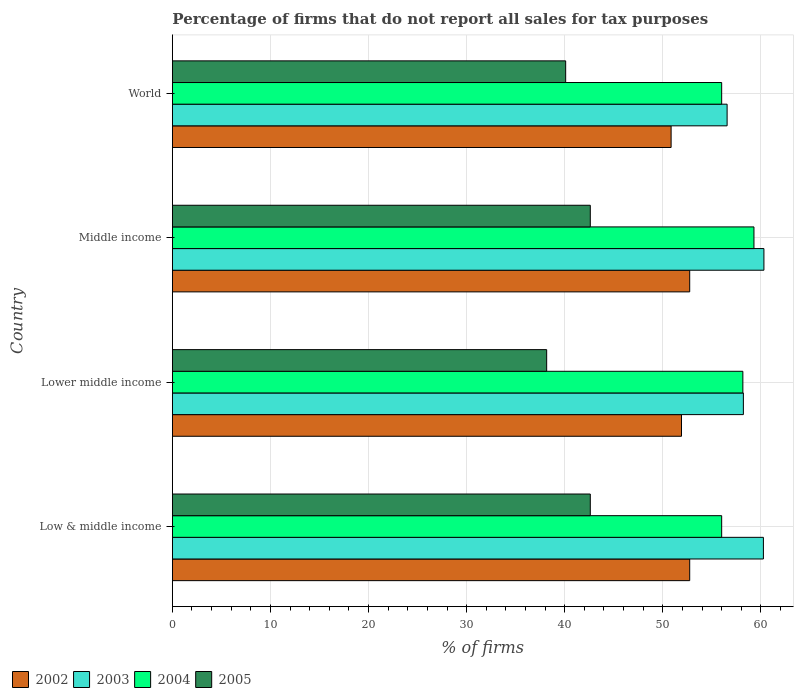How many different coloured bars are there?
Offer a terse response. 4. Are the number of bars on each tick of the Y-axis equal?
Your response must be concise. Yes. How many bars are there on the 1st tick from the top?
Your answer should be compact. 4. How many bars are there on the 2nd tick from the bottom?
Make the answer very short. 4. What is the label of the 3rd group of bars from the top?
Make the answer very short. Lower middle income. What is the percentage of firms that do not report all sales for tax purposes in 2004 in World?
Make the answer very short. 56.01. Across all countries, what is the maximum percentage of firms that do not report all sales for tax purposes in 2004?
Offer a very short reply. 59.3. Across all countries, what is the minimum percentage of firms that do not report all sales for tax purposes in 2005?
Keep it short and to the point. 38.16. In which country was the percentage of firms that do not report all sales for tax purposes in 2004 maximum?
Your response must be concise. Middle income. In which country was the percentage of firms that do not report all sales for tax purposes in 2004 minimum?
Give a very brief answer. Low & middle income. What is the total percentage of firms that do not report all sales for tax purposes in 2004 in the graph?
Provide a short and direct response. 229.47. What is the difference between the percentage of firms that do not report all sales for tax purposes in 2004 in Lower middle income and that in World?
Your answer should be compact. 2.16. What is the difference between the percentage of firms that do not report all sales for tax purposes in 2005 in Middle income and the percentage of firms that do not report all sales for tax purposes in 2004 in World?
Your response must be concise. -13.39. What is the average percentage of firms that do not report all sales for tax purposes in 2004 per country?
Keep it short and to the point. 57.37. What is the difference between the percentage of firms that do not report all sales for tax purposes in 2005 and percentage of firms that do not report all sales for tax purposes in 2004 in Middle income?
Give a very brief answer. -16.69. In how many countries, is the percentage of firms that do not report all sales for tax purposes in 2002 greater than 48 %?
Provide a short and direct response. 4. What is the ratio of the percentage of firms that do not report all sales for tax purposes in 2002 in Lower middle income to that in Middle income?
Give a very brief answer. 0.98. What is the difference between the highest and the second highest percentage of firms that do not report all sales for tax purposes in 2005?
Your answer should be compact. 0. What is the difference between the highest and the lowest percentage of firms that do not report all sales for tax purposes in 2003?
Give a very brief answer. 3.75. In how many countries, is the percentage of firms that do not report all sales for tax purposes in 2004 greater than the average percentage of firms that do not report all sales for tax purposes in 2004 taken over all countries?
Ensure brevity in your answer.  2. Is the sum of the percentage of firms that do not report all sales for tax purposes in 2004 in Low & middle income and World greater than the maximum percentage of firms that do not report all sales for tax purposes in 2003 across all countries?
Offer a terse response. Yes. Is it the case that in every country, the sum of the percentage of firms that do not report all sales for tax purposes in 2005 and percentage of firms that do not report all sales for tax purposes in 2002 is greater than the sum of percentage of firms that do not report all sales for tax purposes in 2004 and percentage of firms that do not report all sales for tax purposes in 2003?
Offer a very short reply. No. What does the 4th bar from the top in Middle income represents?
Provide a short and direct response. 2002. Is it the case that in every country, the sum of the percentage of firms that do not report all sales for tax purposes in 2002 and percentage of firms that do not report all sales for tax purposes in 2003 is greater than the percentage of firms that do not report all sales for tax purposes in 2005?
Make the answer very short. Yes. How many bars are there?
Provide a succinct answer. 16. Are the values on the major ticks of X-axis written in scientific E-notation?
Offer a very short reply. No. Does the graph contain grids?
Your response must be concise. Yes. How are the legend labels stacked?
Your answer should be compact. Horizontal. What is the title of the graph?
Make the answer very short. Percentage of firms that do not report all sales for tax purposes. Does "2011" appear as one of the legend labels in the graph?
Give a very brief answer. No. What is the label or title of the X-axis?
Your response must be concise. % of firms. What is the % of firms of 2002 in Low & middle income?
Offer a terse response. 52.75. What is the % of firms of 2003 in Low & middle income?
Provide a succinct answer. 60.26. What is the % of firms in 2004 in Low & middle income?
Give a very brief answer. 56.01. What is the % of firms in 2005 in Low & middle income?
Offer a very short reply. 42.61. What is the % of firms in 2002 in Lower middle income?
Your answer should be compact. 51.91. What is the % of firms of 2003 in Lower middle income?
Your response must be concise. 58.22. What is the % of firms of 2004 in Lower middle income?
Your answer should be very brief. 58.16. What is the % of firms of 2005 in Lower middle income?
Your answer should be very brief. 38.16. What is the % of firms of 2002 in Middle income?
Your answer should be very brief. 52.75. What is the % of firms in 2003 in Middle income?
Ensure brevity in your answer.  60.31. What is the % of firms of 2004 in Middle income?
Your answer should be very brief. 59.3. What is the % of firms in 2005 in Middle income?
Ensure brevity in your answer.  42.61. What is the % of firms of 2002 in World?
Offer a terse response. 50.85. What is the % of firms of 2003 in World?
Your response must be concise. 56.56. What is the % of firms of 2004 in World?
Ensure brevity in your answer.  56.01. What is the % of firms in 2005 in World?
Make the answer very short. 40.1. Across all countries, what is the maximum % of firms of 2002?
Provide a succinct answer. 52.75. Across all countries, what is the maximum % of firms in 2003?
Offer a very short reply. 60.31. Across all countries, what is the maximum % of firms in 2004?
Ensure brevity in your answer.  59.3. Across all countries, what is the maximum % of firms in 2005?
Offer a very short reply. 42.61. Across all countries, what is the minimum % of firms of 2002?
Your answer should be compact. 50.85. Across all countries, what is the minimum % of firms of 2003?
Offer a terse response. 56.56. Across all countries, what is the minimum % of firms in 2004?
Your answer should be compact. 56.01. Across all countries, what is the minimum % of firms of 2005?
Ensure brevity in your answer.  38.16. What is the total % of firms in 2002 in the graph?
Provide a short and direct response. 208.25. What is the total % of firms in 2003 in the graph?
Make the answer very short. 235.35. What is the total % of firms of 2004 in the graph?
Offer a very short reply. 229.47. What is the total % of firms in 2005 in the graph?
Your response must be concise. 163.48. What is the difference between the % of firms in 2002 in Low & middle income and that in Lower middle income?
Offer a terse response. 0.84. What is the difference between the % of firms in 2003 in Low & middle income and that in Lower middle income?
Keep it short and to the point. 2.04. What is the difference between the % of firms of 2004 in Low & middle income and that in Lower middle income?
Provide a succinct answer. -2.16. What is the difference between the % of firms in 2005 in Low & middle income and that in Lower middle income?
Your answer should be compact. 4.45. What is the difference between the % of firms of 2003 in Low & middle income and that in Middle income?
Offer a very short reply. -0.05. What is the difference between the % of firms of 2004 in Low & middle income and that in Middle income?
Your response must be concise. -3.29. What is the difference between the % of firms in 2002 in Low & middle income and that in World?
Offer a terse response. 1.89. What is the difference between the % of firms in 2004 in Low & middle income and that in World?
Offer a terse response. 0. What is the difference between the % of firms of 2005 in Low & middle income and that in World?
Your answer should be very brief. 2.51. What is the difference between the % of firms of 2002 in Lower middle income and that in Middle income?
Your response must be concise. -0.84. What is the difference between the % of firms in 2003 in Lower middle income and that in Middle income?
Provide a short and direct response. -2.09. What is the difference between the % of firms of 2004 in Lower middle income and that in Middle income?
Offer a very short reply. -1.13. What is the difference between the % of firms of 2005 in Lower middle income and that in Middle income?
Ensure brevity in your answer.  -4.45. What is the difference between the % of firms of 2002 in Lower middle income and that in World?
Provide a succinct answer. 1.06. What is the difference between the % of firms of 2003 in Lower middle income and that in World?
Provide a short and direct response. 1.66. What is the difference between the % of firms in 2004 in Lower middle income and that in World?
Your response must be concise. 2.16. What is the difference between the % of firms in 2005 in Lower middle income and that in World?
Make the answer very short. -1.94. What is the difference between the % of firms in 2002 in Middle income and that in World?
Give a very brief answer. 1.89. What is the difference between the % of firms of 2003 in Middle income and that in World?
Your answer should be very brief. 3.75. What is the difference between the % of firms in 2004 in Middle income and that in World?
Provide a short and direct response. 3.29. What is the difference between the % of firms of 2005 in Middle income and that in World?
Make the answer very short. 2.51. What is the difference between the % of firms in 2002 in Low & middle income and the % of firms in 2003 in Lower middle income?
Offer a very short reply. -5.47. What is the difference between the % of firms in 2002 in Low & middle income and the % of firms in 2004 in Lower middle income?
Offer a terse response. -5.42. What is the difference between the % of firms of 2002 in Low & middle income and the % of firms of 2005 in Lower middle income?
Your response must be concise. 14.58. What is the difference between the % of firms of 2003 in Low & middle income and the % of firms of 2004 in Lower middle income?
Provide a succinct answer. 2.1. What is the difference between the % of firms of 2003 in Low & middle income and the % of firms of 2005 in Lower middle income?
Your response must be concise. 22.1. What is the difference between the % of firms of 2004 in Low & middle income and the % of firms of 2005 in Lower middle income?
Offer a very short reply. 17.84. What is the difference between the % of firms of 2002 in Low & middle income and the % of firms of 2003 in Middle income?
Make the answer very short. -7.57. What is the difference between the % of firms in 2002 in Low & middle income and the % of firms in 2004 in Middle income?
Make the answer very short. -6.55. What is the difference between the % of firms of 2002 in Low & middle income and the % of firms of 2005 in Middle income?
Your response must be concise. 10.13. What is the difference between the % of firms in 2003 in Low & middle income and the % of firms in 2004 in Middle income?
Offer a very short reply. 0.96. What is the difference between the % of firms of 2003 in Low & middle income and the % of firms of 2005 in Middle income?
Your answer should be compact. 17.65. What is the difference between the % of firms of 2004 in Low & middle income and the % of firms of 2005 in Middle income?
Offer a very short reply. 13.39. What is the difference between the % of firms of 2002 in Low & middle income and the % of firms of 2003 in World?
Your answer should be very brief. -3.81. What is the difference between the % of firms of 2002 in Low & middle income and the % of firms of 2004 in World?
Your answer should be very brief. -3.26. What is the difference between the % of firms in 2002 in Low & middle income and the % of firms in 2005 in World?
Provide a succinct answer. 12.65. What is the difference between the % of firms in 2003 in Low & middle income and the % of firms in 2004 in World?
Keep it short and to the point. 4.25. What is the difference between the % of firms in 2003 in Low & middle income and the % of firms in 2005 in World?
Offer a very short reply. 20.16. What is the difference between the % of firms in 2004 in Low & middle income and the % of firms in 2005 in World?
Provide a succinct answer. 15.91. What is the difference between the % of firms in 2002 in Lower middle income and the % of firms in 2003 in Middle income?
Keep it short and to the point. -8.4. What is the difference between the % of firms in 2002 in Lower middle income and the % of firms in 2004 in Middle income?
Keep it short and to the point. -7.39. What is the difference between the % of firms in 2002 in Lower middle income and the % of firms in 2005 in Middle income?
Give a very brief answer. 9.3. What is the difference between the % of firms of 2003 in Lower middle income and the % of firms of 2004 in Middle income?
Give a very brief answer. -1.08. What is the difference between the % of firms of 2003 in Lower middle income and the % of firms of 2005 in Middle income?
Your answer should be compact. 15.61. What is the difference between the % of firms in 2004 in Lower middle income and the % of firms in 2005 in Middle income?
Provide a short and direct response. 15.55. What is the difference between the % of firms of 2002 in Lower middle income and the % of firms of 2003 in World?
Provide a succinct answer. -4.65. What is the difference between the % of firms of 2002 in Lower middle income and the % of firms of 2004 in World?
Provide a short and direct response. -4.1. What is the difference between the % of firms of 2002 in Lower middle income and the % of firms of 2005 in World?
Offer a terse response. 11.81. What is the difference between the % of firms of 2003 in Lower middle income and the % of firms of 2004 in World?
Ensure brevity in your answer.  2.21. What is the difference between the % of firms of 2003 in Lower middle income and the % of firms of 2005 in World?
Your answer should be very brief. 18.12. What is the difference between the % of firms of 2004 in Lower middle income and the % of firms of 2005 in World?
Your answer should be very brief. 18.07. What is the difference between the % of firms in 2002 in Middle income and the % of firms in 2003 in World?
Provide a short and direct response. -3.81. What is the difference between the % of firms of 2002 in Middle income and the % of firms of 2004 in World?
Make the answer very short. -3.26. What is the difference between the % of firms in 2002 in Middle income and the % of firms in 2005 in World?
Offer a very short reply. 12.65. What is the difference between the % of firms of 2003 in Middle income and the % of firms of 2004 in World?
Offer a very short reply. 4.31. What is the difference between the % of firms of 2003 in Middle income and the % of firms of 2005 in World?
Offer a very short reply. 20.21. What is the difference between the % of firms of 2004 in Middle income and the % of firms of 2005 in World?
Ensure brevity in your answer.  19.2. What is the average % of firms of 2002 per country?
Keep it short and to the point. 52.06. What is the average % of firms in 2003 per country?
Provide a succinct answer. 58.84. What is the average % of firms of 2004 per country?
Ensure brevity in your answer.  57.37. What is the average % of firms in 2005 per country?
Offer a terse response. 40.87. What is the difference between the % of firms in 2002 and % of firms in 2003 in Low & middle income?
Make the answer very short. -7.51. What is the difference between the % of firms of 2002 and % of firms of 2004 in Low & middle income?
Provide a succinct answer. -3.26. What is the difference between the % of firms in 2002 and % of firms in 2005 in Low & middle income?
Offer a very short reply. 10.13. What is the difference between the % of firms in 2003 and % of firms in 2004 in Low & middle income?
Your answer should be very brief. 4.25. What is the difference between the % of firms of 2003 and % of firms of 2005 in Low & middle income?
Offer a very short reply. 17.65. What is the difference between the % of firms of 2004 and % of firms of 2005 in Low & middle income?
Offer a very short reply. 13.39. What is the difference between the % of firms of 2002 and % of firms of 2003 in Lower middle income?
Make the answer very short. -6.31. What is the difference between the % of firms in 2002 and % of firms in 2004 in Lower middle income?
Your response must be concise. -6.26. What is the difference between the % of firms of 2002 and % of firms of 2005 in Lower middle income?
Provide a succinct answer. 13.75. What is the difference between the % of firms in 2003 and % of firms in 2004 in Lower middle income?
Offer a very short reply. 0.05. What is the difference between the % of firms of 2003 and % of firms of 2005 in Lower middle income?
Ensure brevity in your answer.  20.06. What is the difference between the % of firms of 2004 and % of firms of 2005 in Lower middle income?
Offer a very short reply. 20. What is the difference between the % of firms of 2002 and % of firms of 2003 in Middle income?
Offer a very short reply. -7.57. What is the difference between the % of firms of 2002 and % of firms of 2004 in Middle income?
Your answer should be compact. -6.55. What is the difference between the % of firms in 2002 and % of firms in 2005 in Middle income?
Keep it short and to the point. 10.13. What is the difference between the % of firms of 2003 and % of firms of 2004 in Middle income?
Keep it short and to the point. 1.02. What is the difference between the % of firms in 2003 and % of firms in 2005 in Middle income?
Your response must be concise. 17.7. What is the difference between the % of firms of 2004 and % of firms of 2005 in Middle income?
Your response must be concise. 16.69. What is the difference between the % of firms of 2002 and % of firms of 2003 in World?
Make the answer very short. -5.71. What is the difference between the % of firms of 2002 and % of firms of 2004 in World?
Ensure brevity in your answer.  -5.15. What is the difference between the % of firms of 2002 and % of firms of 2005 in World?
Ensure brevity in your answer.  10.75. What is the difference between the % of firms in 2003 and % of firms in 2004 in World?
Provide a succinct answer. 0.56. What is the difference between the % of firms of 2003 and % of firms of 2005 in World?
Your answer should be very brief. 16.46. What is the difference between the % of firms of 2004 and % of firms of 2005 in World?
Provide a succinct answer. 15.91. What is the ratio of the % of firms of 2002 in Low & middle income to that in Lower middle income?
Offer a terse response. 1.02. What is the ratio of the % of firms of 2003 in Low & middle income to that in Lower middle income?
Ensure brevity in your answer.  1.04. What is the ratio of the % of firms of 2004 in Low & middle income to that in Lower middle income?
Your answer should be very brief. 0.96. What is the ratio of the % of firms in 2005 in Low & middle income to that in Lower middle income?
Keep it short and to the point. 1.12. What is the ratio of the % of firms in 2002 in Low & middle income to that in Middle income?
Ensure brevity in your answer.  1. What is the ratio of the % of firms of 2004 in Low & middle income to that in Middle income?
Give a very brief answer. 0.94. What is the ratio of the % of firms in 2005 in Low & middle income to that in Middle income?
Ensure brevity in your answer.  1. What is the ratio of the % of firms in 2002 in Low & middle income to that in World?
Your response must be concise. 1.04. What is the ratio of the % of firms in 2003 in Low & middle income to that in World?
Provide a short and direct response. 1.07. What is the ratio of the % of firms in 2005 in Low & middle income to that in World?
Give a very brief answer. 1.06. What is the ratio of the % of firms of 2002 in Lower middle income to that in Middle income?
Keep it short and to the point. 0.98. What is the ratio of the % of firms of 2003 in Lower middle income to that in Middle income?
Your response must be concise. 0.97. What is the ratio of the % of firms in 2004 in Lower middle income to that in Middle income?
Make the answer very short. 0.98. What is the ratio of the % of firms of 2005 in Lower middle income to that in Middle income?
Make the answer very short. 0.9. What is the ratio of the % of firms of 2002 in Lower middle income to that in World?
Provide a short and direct response. 1.02. What is the ratio of the % of firms of 2003 in Lower middle income to that in World?
Provide a short and direct response. 1.03. What is the ratio of the % of firms in 2004 in Lower middle income to that in World?
Your answer should be compact. 1.04. What is the ratio of the % of firms in 2005 in Lower middle income to that in World?
Give a very brief answer. 0.95. What is the ratio of the % of firms in 2002 in Middle income to that in World?
Ensure brevity in your answer.  1.04. What is the ratio of the % of firms in 2003 in Middle income to that in World?
Make the answer very short. 1.07. What is the ratio of the % of firms of 2004 in Middle income to that in World?
Ensure brevity in your answer.  1.06. What is the ratio of the % of firms of 2005 in Middle income to that in World?
Your answer should be very brief. 1.06. What is the difference between the highest and the second highest % of firms in 2003?
Your response must be concise. 0.05. What is the difference between the highest and the second highest % of firms in 2004?
Offer a very short reply. 1.13. What is the difference between the highest and the second highest % of firms in 2005?
Offer a terse response. 0. What is the difference between the highest and the lowest % of firms of 2002?
Offer a very short reply. 1.89. What is the difference between the highest and the lowest % of firms of 2003?
Offer a very short reply. 3.75. What is the difference between the highest and the lowest % of firms in 2004?
Provide a succinct answer. 3.29. What is the difference between the highest and the lowest % of firms of 2005?
Provide a succinct answer. 4.45. 